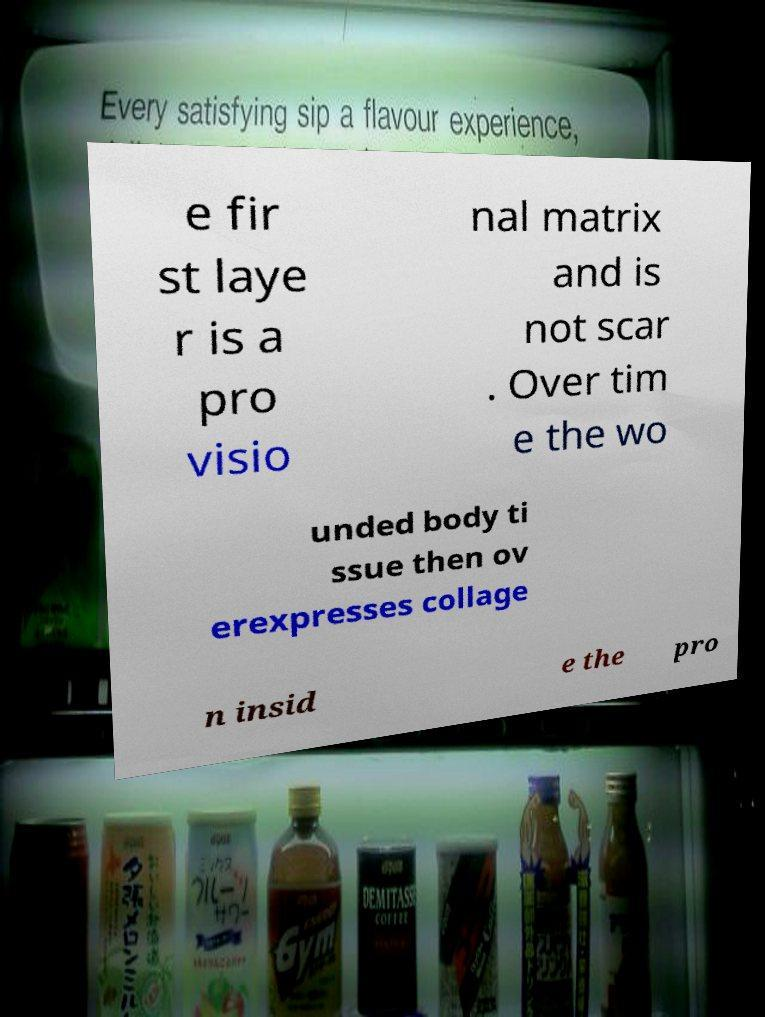I need the written content from this picture converted into text. Can you do that? e fir st laye r is a pro visio nal matrix and is not scar . Over tim e the wo unded body ti ssue then ov erexpresses collage n insid e the pro 